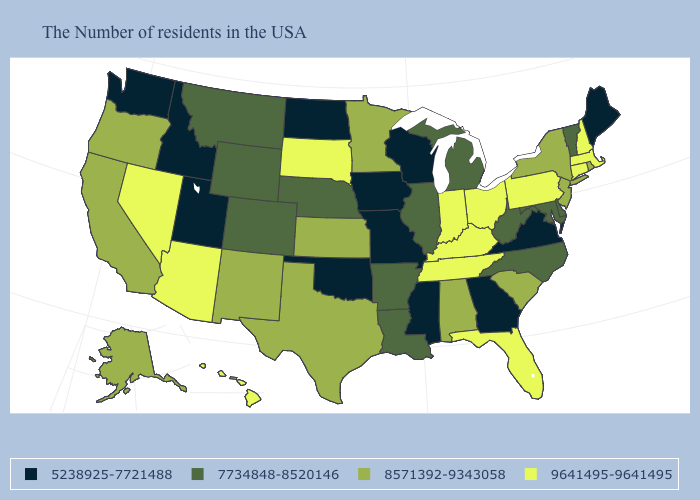What is the highest value in the USA?
Be succinct. 9641495-9641495. Is the legend a continuous bar?
Be succinct. No. Does Indiana have the highest value in the USA?
Answer briefly. Yes. What is the highest value in the West ?
Give a very brief answer. 9641495-9641495. What is the value of Florida?
Write a very short answer. 9641495-9641495. Does New Mexico have a lower value than Florida?
Write a very short answer. Yes. What is the lowest value in states that border Virginia?
Be succinct. 7734848-8520146. What is the highest value in states that border New York?
Short answer required. 9641495-9641495. Which states have the highest value in the USA?
Keep it brief. Massachusetts, New Hampshire, Connecticut, Pennsylvania, Ohio, Florida, Kentucky, Indiana, Tennessee, South Dakota, Arizona, Nevada, Hawaii. Name the states that have a value in the range 7734848-8520146?
Concise answer only. Vermont, Delaware, Maryland, North Carolina, West Virginia, Michigan, Illinois, Louisiana, Arkansas, Nebraska, Wyoming, Colorado, Montana. Which states have the highest value in the USA?
Short answer required. Massachusetts, New Hampshire, Connecticut, Pennsylvania, Ohio, Florida, Kentucky, Indiana, Tennessee, South Dakota, Arizona, Nevada, Hawaii. What is the value of Alaska?
Write a very short answer. 8571392-9343058. Name the states that have a value in the range 9641495-9641495?
Short answer required. Massachusetts, New Hampshire, Connecticut, Pennsylvania, Ohio, Florida, Kentucky, Indiana, Tennessee, South Dakota, Arizona, Nevada, Hawaii. Does Nevada have the highest value in the West?
Write a very short answer. Yes. What is the value of Missouri?
Answer briefly. 5238925-7721488. 